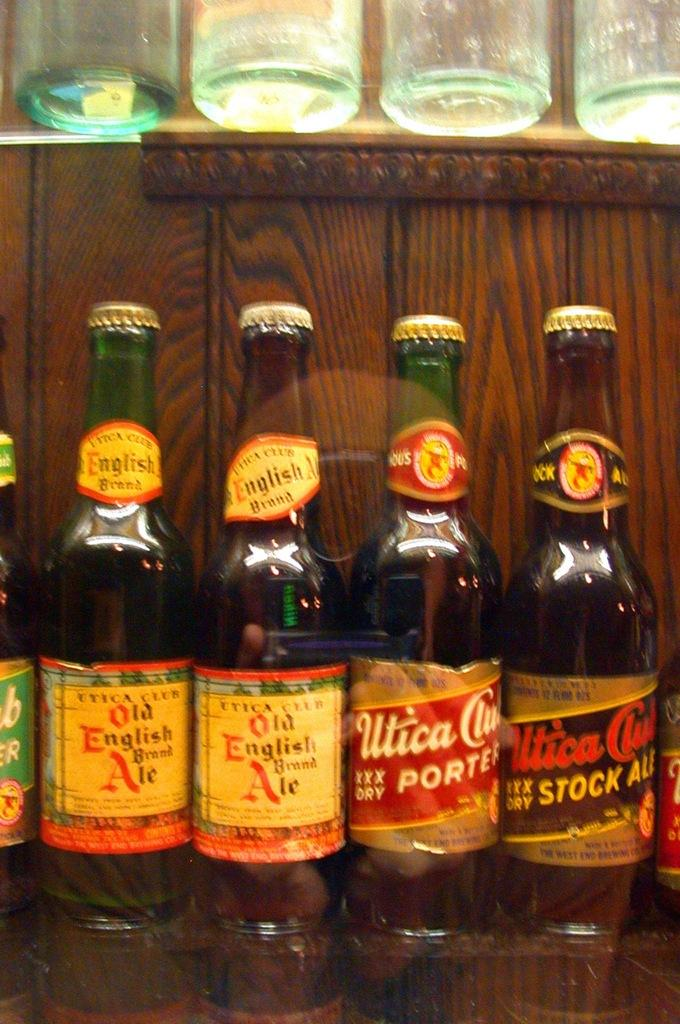Provide a one-sentence caption for the provided image. several bottles of beer lined up including Old English Ale. 